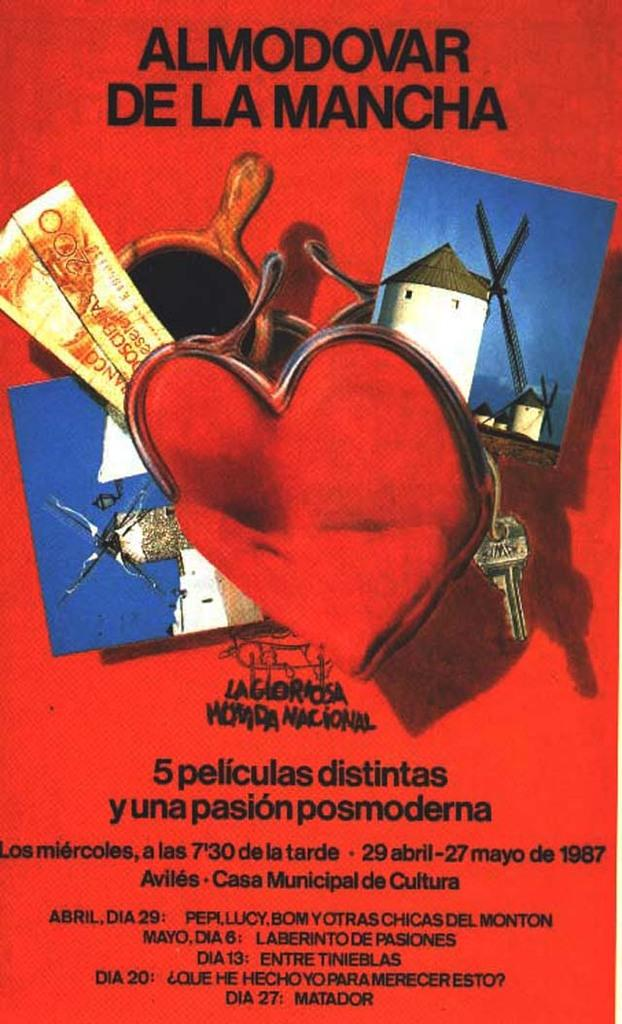<image>
Create a compact narrative representing the image presented. A poster says Almodovar De La Manchar, 5 peliculas distintas y una pasion posmoderna. 